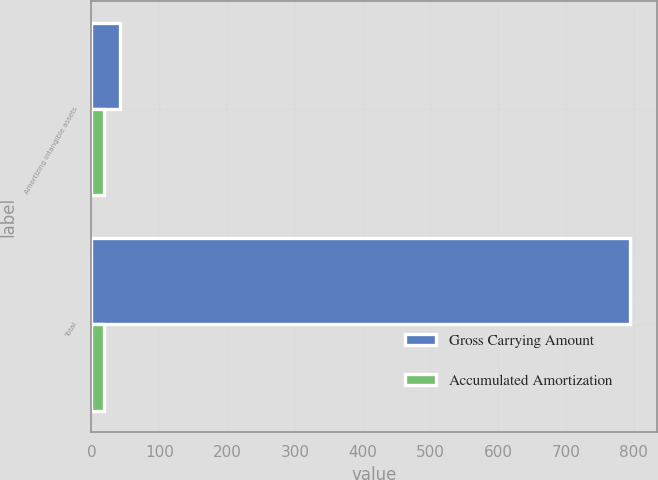Convert chart. <chart><loc_0><loc_0><loc_500><loc_500><stacked_bar_chart><ecel><fcel>Amortizing intangible assets<fcel>Total<nl><fcel>Gross Carrying Amount<fcel>41.9<fcel>794.5<nl><fcel>Accumulated Amortization<fcel>18.5<fcel>18.5<nl></chart> 